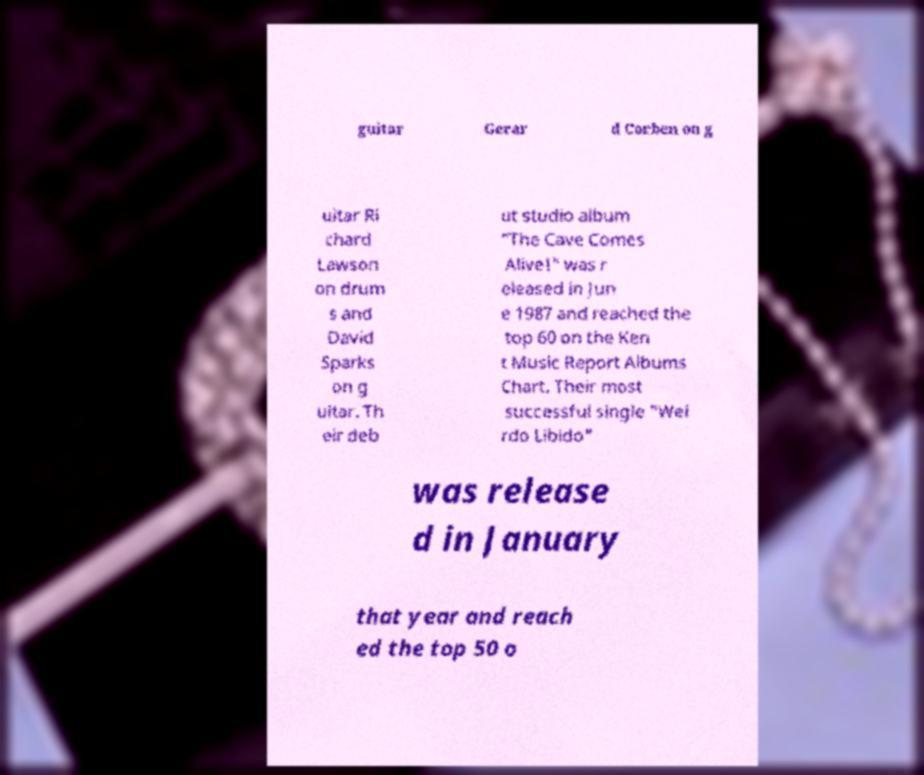Could you extract and type out the text from this image? guitar Gerar d Corben on g uitar Ri chard Lawson on drum s and David Sparks on g uitar. Th eir deb ut studio album "The Cave Comes Alive!" was r eleased in Jun e 1987 and reached the top 60 on the Ken t Music Report Albums Chart. Their most successful single "Wei rdo Libido" was release d in January that year and reach ed the top 50 o 